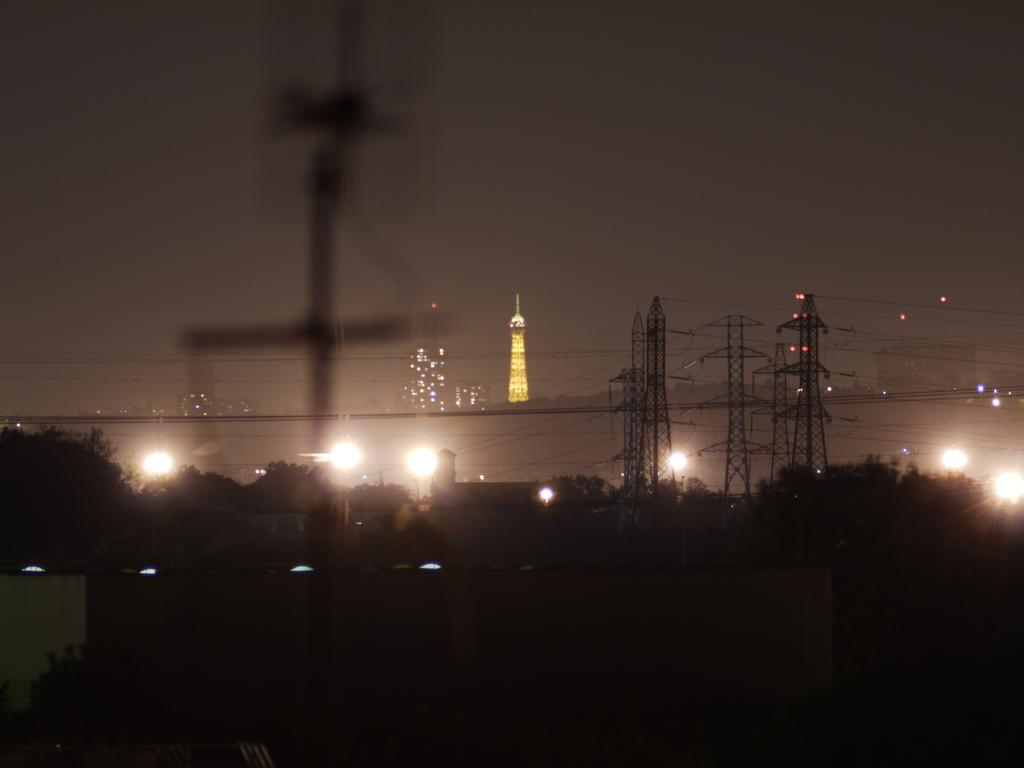What type of structures can be seen in the image? There are buildings, towers, and lights visible in the image. What other natural elements can be seen in the image? There are trees and clouds present in the image. What is visible in the background of the image? The sky is visible in the background of the image. What type of game is being played on the linen in the image? There is no game or linen present in the image. Who is the coach in the image? There is no coach present in the image. 